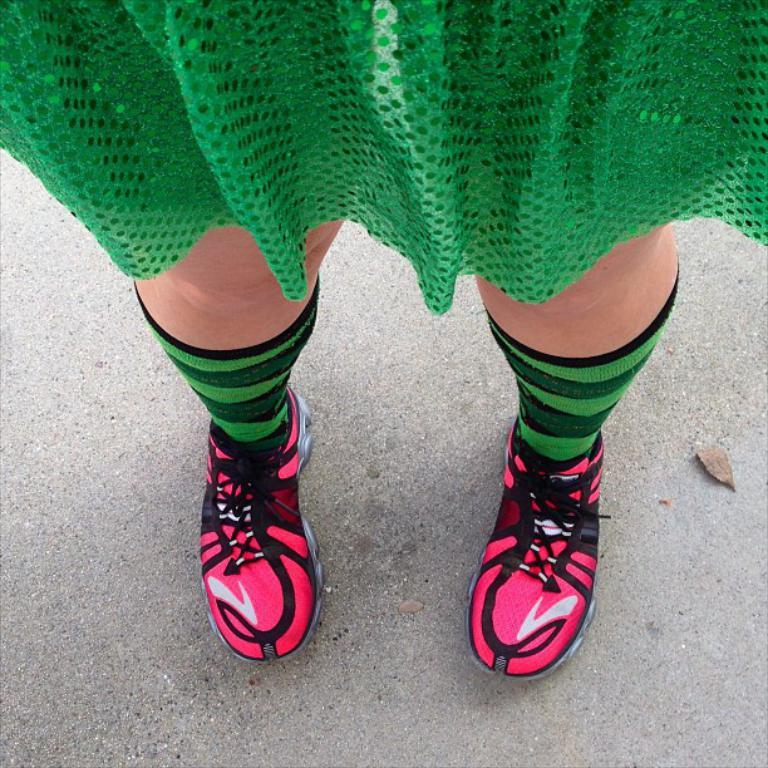What is present in the image? There is a person in the image. What is the person wearing? The person is wearing a green dress. Where is the person located in the image? The person is standing on a path. What type of drum can be seen being played by the person in the image? There is no drum present in the image, and the person is not playing any musical instrument. Is the person wearing a crown in the image? No, the person is not wearing a crown in the image; they are wearing a green dress. 